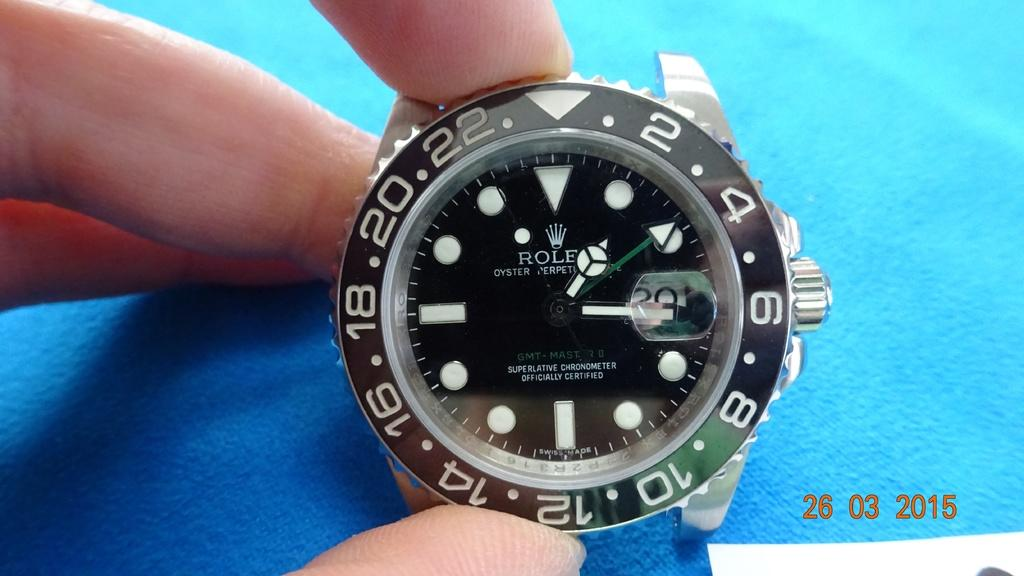<image>
Present a compact description of the photo's key features. A Rolex watch without a band is being held over a blue cloth. 